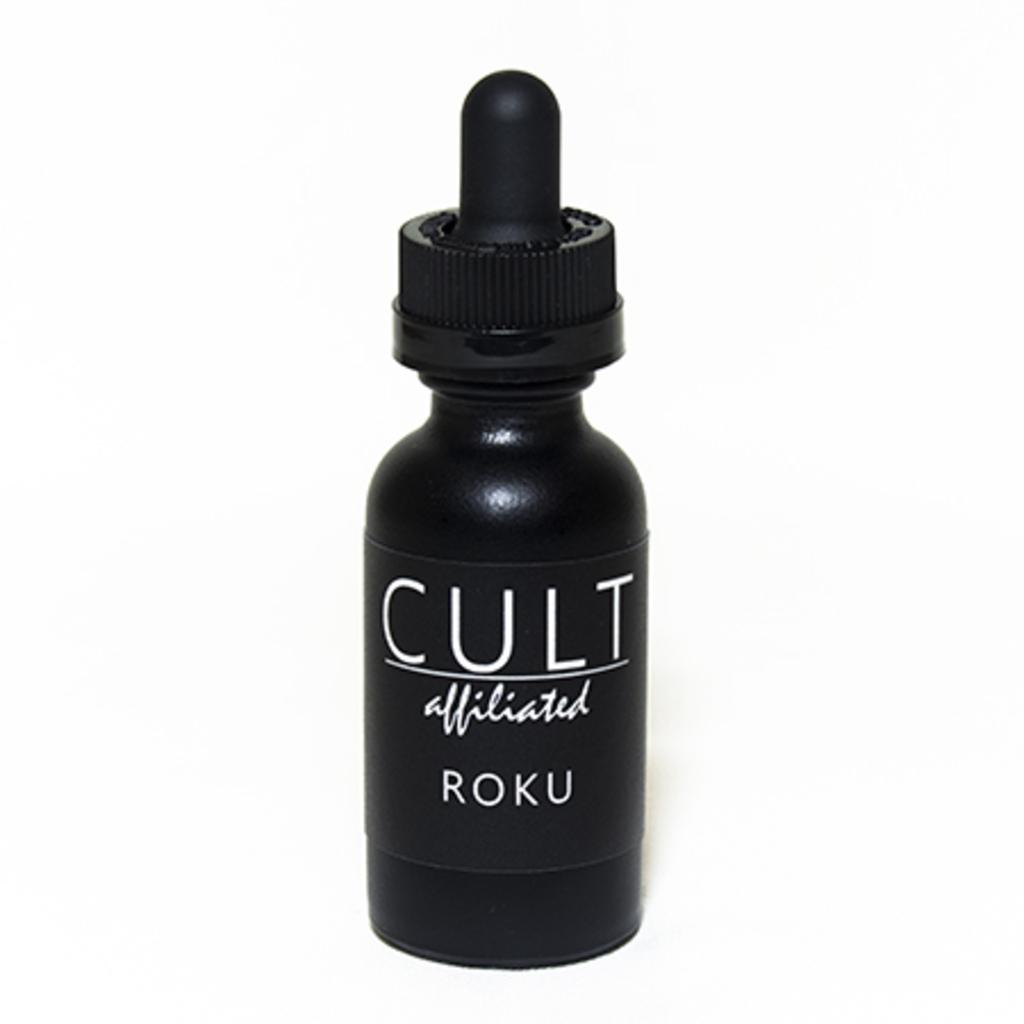What is the color of the bottle in the image? The bottle in the image is black. What can be found on the bottle's label? The label on the bottle has text. What color is the background of the image? The background of the image is white. What kind of idea is being expressed by the flame coming from the bottle in the image? There is no flame present in the image, and therefore no idea can be expressed by it. 